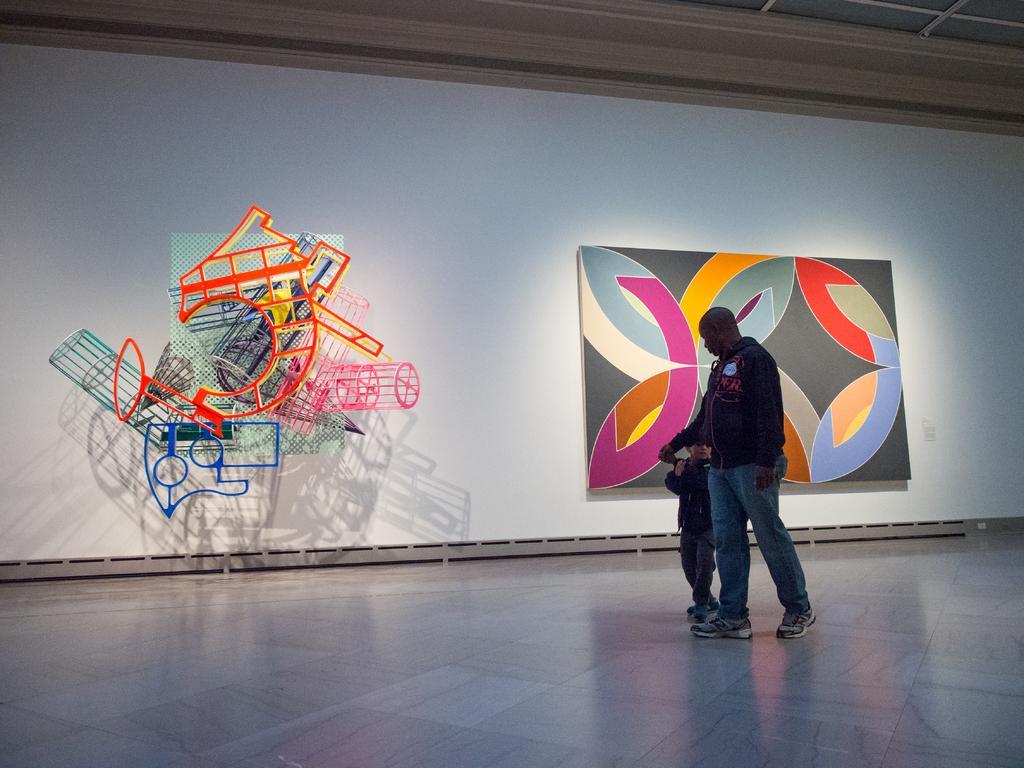Describe this image in one or two sentences. In this image we can a person and child on the stage, there we can see a screen where a board and some objects attached to it, there we can also see the ceiling. 